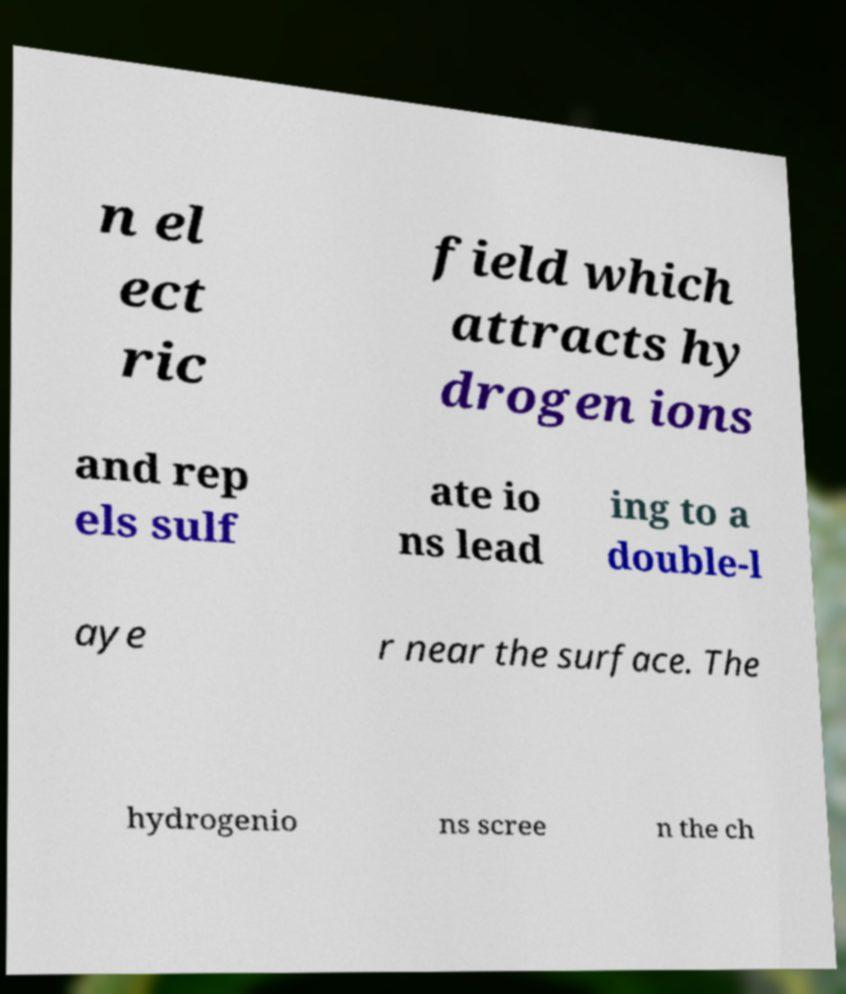For documentation purposes, I need the text within this image transcribed. Could you provide that? n el ect ric field which attracts hy drogen ions and rep els sulf ate io ns lead ing to a double-l aye r near the surface. The hydrogenio ns scree n the ch 